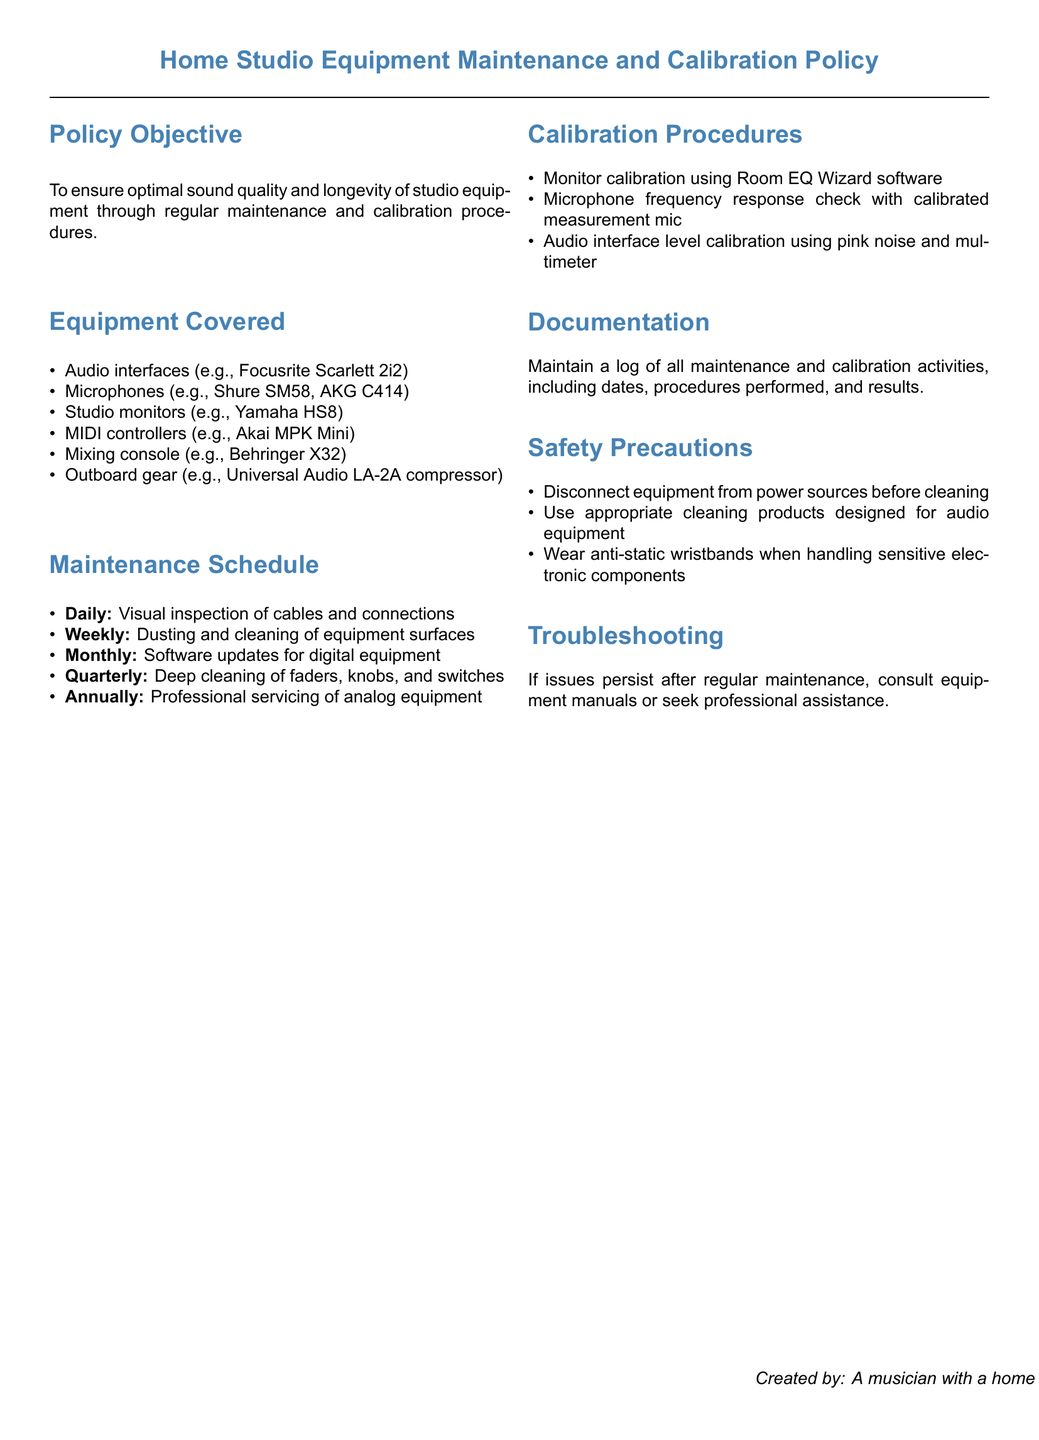What is the policy objective? The policy objective is to ensure optimal sound quality and longevity of studio equipment through regular maintenance and calibration procedures.
Answer: Ensure optimal sound quality and longevity of studio equipment What type of equipment is covered? The types of equipment covered include audio interfaces, microphones, studio monitors, MIDI controllers, mixing consoles, and outboard gear.
Answer: Audio interfaces, microphones, studio monitors, MIDI controllers, mixing consoles, outboard gear How often should deep cleaning be performed? Deep cleaning should be performed quarterly according to the maintenance schedule.
Answer: Quarterly What software is used for monitor calibration? The document specifies Room EQ Wizard software for monitor calibration.
Answer: Room EQ Wizard What is the annual maintenance procedure for analog equipment? The annual maintenance procedure for analog equipment is professional servicing.
Answer: Professional servicing What should be maintained to track maintenance activities? A log should be maintained to track all maintenance and calibration activities, including dates, procedures performed, and results.
Answer: Log of all maintenance and calibration activities What action should be taken before cleaning equipment? The document states that equipment should be disconnected from power sources before cleaning.
Answer: Disconnect equipment from power sources When should microphone frequency response checks be conducted? The frequency response checks should be conducted as part of the calibration procedures; the document does not specify a frequency but implies it should be a regular activity.
Answer: As part of the calibration procedures 